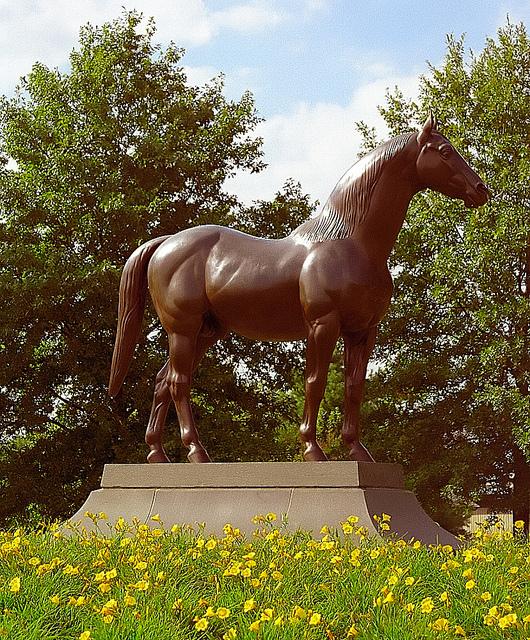Is there a statue?
Keep it brief. Yes. What color are the flowers?
Short answer required. Yellow. Is this horse real or a statue?
Give a very brief answer. Statue. 